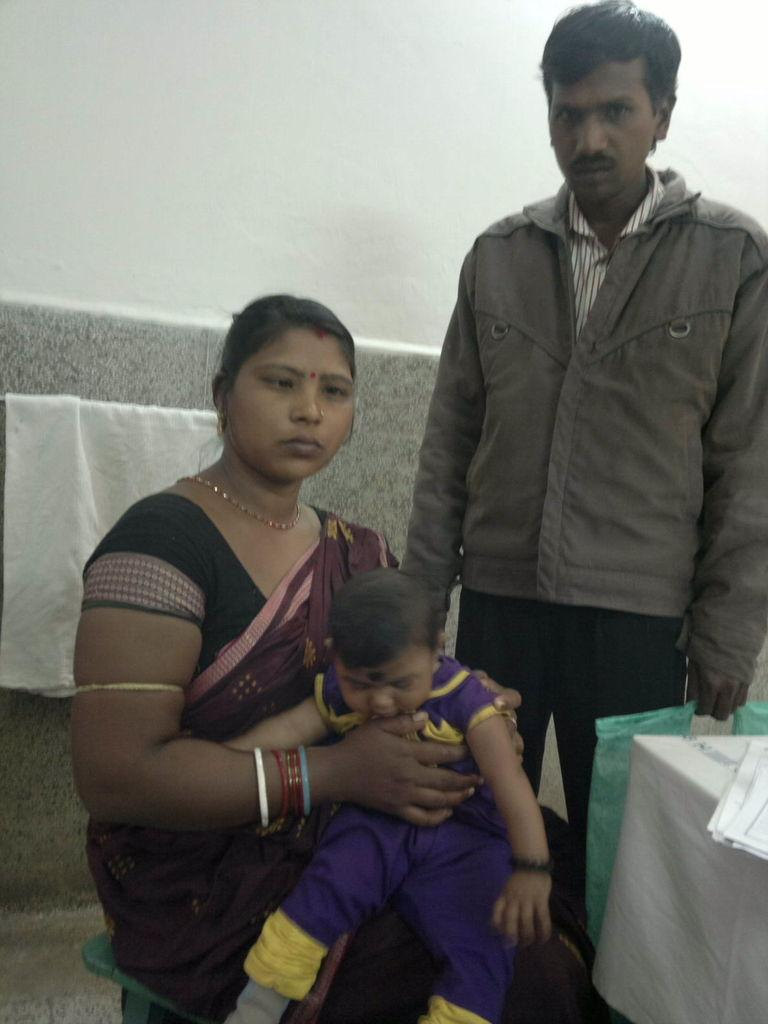What is the woman in the image doing? The woman is sitting on a chair and holding a baby. What is the standing person holding? The standing person is holding a cover. What can be seen in the background of the image? There is a wall and cloth in the background. What is on the table in the image? There are papers on a table. What type of trucks can be seen in the image? There are no trucks present in the image. What is the name of the baby the woman is holding? The name of the baby cannot be determined from the image. 